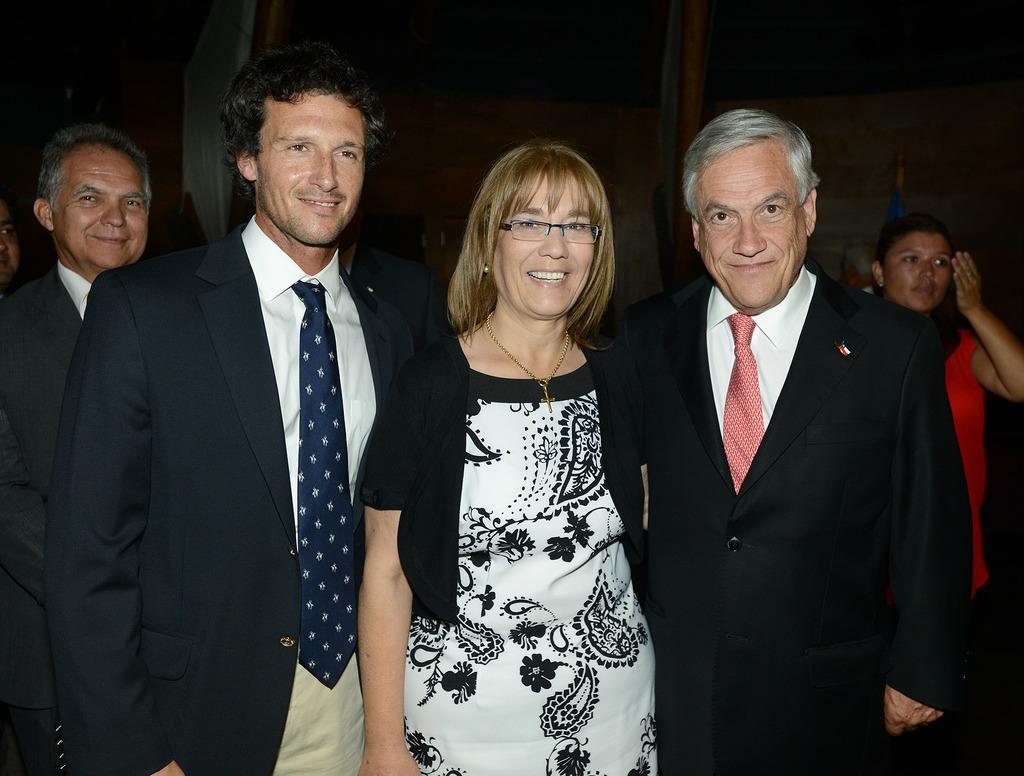In one or two sentences, can you explain what this image depicts? In this picture there are group of people standing and smiling. At the back there's a wall. 